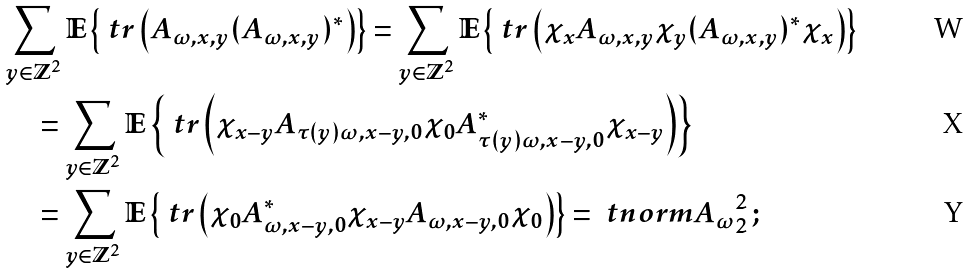Convert formula to latex. <formula><loc_0><loc_0><loc_500><loc_500>& \sum _ { y \in \mathbb { Z } ^ { 2 } } \mathbb { E } \left \{ \ t r \left ( A _ { \omega , x , y } ( A _ { \omega , x , y } ) ^ { * } \right ) \right \} = \sum _ { y \in \mathbb { Z } ^ { 2 } } \mathbb { E } \left \{ \ t r \left ( \chi _ { x } A _ { \omega , x , y } \chi _ { y } ( A _ { \omega , x , y } ) ^ { * } \chi _ { x } \right ) \right \} \\ & \quad = \sum _ { y \in \mathbb { Z } ^ { 2 } } \mathbb { E } \left \{ \ t r \left ( \chi _ { x - y } A _ { \tau ( y ) \omega , x - y , 0 } \chi _ { 0 } A _ { \tau ( y ) \omega , x - y , 0 } ^ { * } \chi _ { x - y } \right ) \right \} \\ & \quad = \sum _ { y \in \mathbb { Z } ^ { 2 } } \mathbb { E } \left \{ \ t r \left ( \chi _ { 0 } A _ { \omega , x - y , 0 } ^ { * } \chi _ { x - y } A _ { \omega , x - y , 0 } \chi _ { 0 } \right ) \right \} = \ t n o r m { A _ { \omega } } _ { 2 } ^ { 2 } \, ;</formula> 